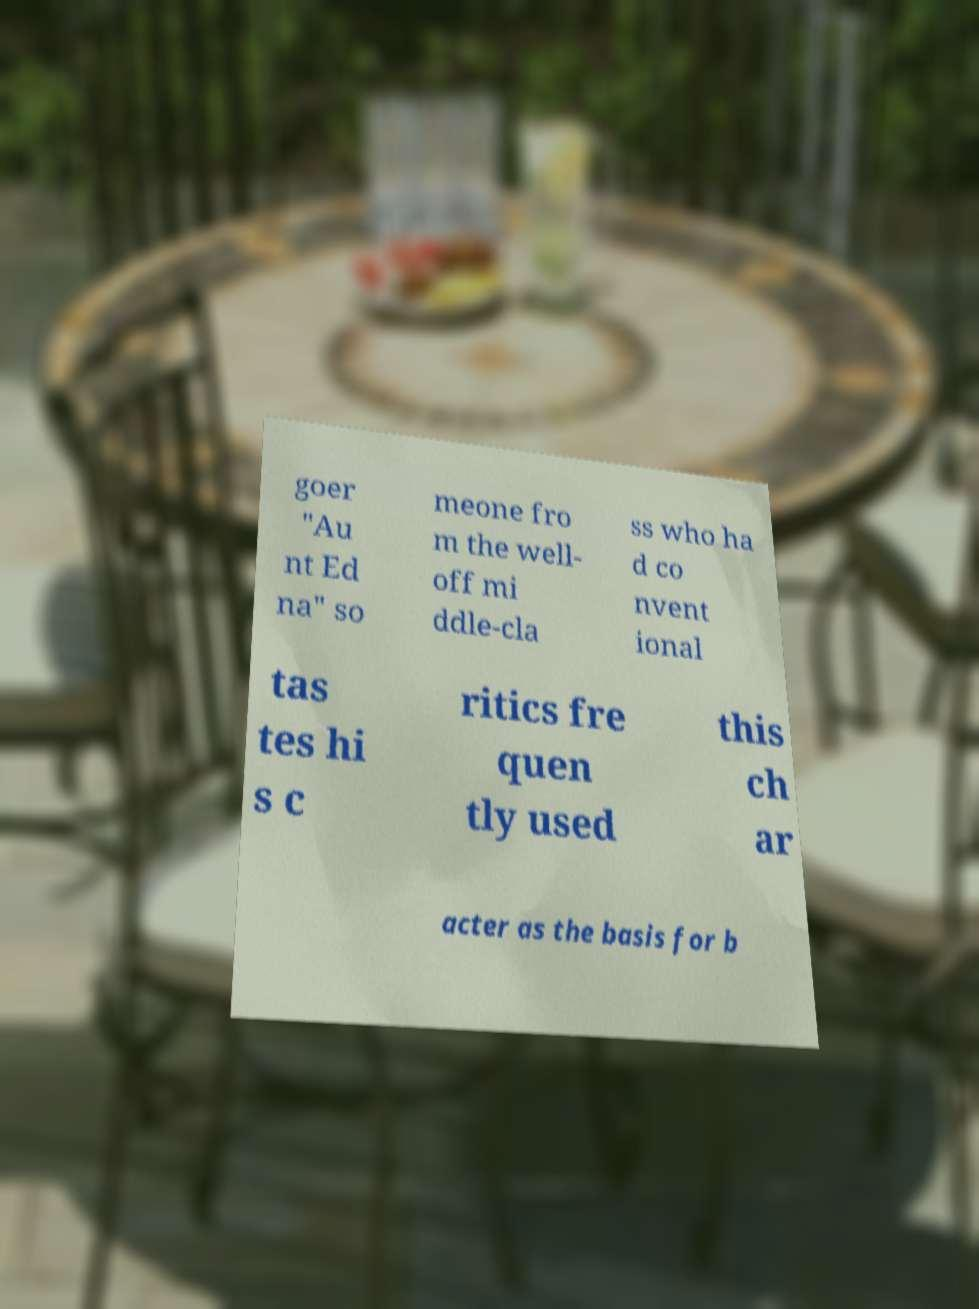Can you read and provide the text displayed in the image?This photo seems to have some interesting text. Can you extract and type it out for me? goer "Au nt Ed na" so meone fro m the well- off mi ddle-cla ss who ha d co nvent ional tas tes hi s c ritics fre quen tly used this ch ar acter as the basis for b 